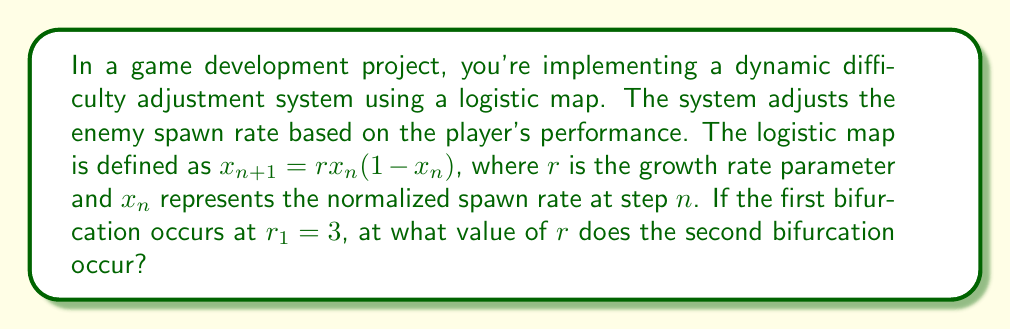Can you answer this question? To solve this problem, we need to understand the behavior of the logistic map and its bifurcations:

1. The logistic map is given by the equation $x_{n+1} = rx_n(1-x_n)$, where $r$ is the growth rate parameter.

2. As $r$ increases, the behavior of the system changes:
   - For $0 < r < 1$, the system converges to 0.
   - For $1 < r < 3$, the system converges to a single non-zero fixed point.
   - At $r = 3$, the first bifurcation occurs, and the system oscillates between two values.

3. The second bifurcation occurs when the system transitions from a 2-cycle to a 4-cycle.

4. The relationship between successive bifurcation points follows the Feigenbaum constant $\delta \approx 4.669201...$.

5. Let $r_1 = 3$ be the first bifurcation point and $r_2$ be the second bifurcation point.

6. The Feigenbaum constant relates these points as follows:
   $$\delta \approx \frac{r_3 - r_2}{r_2 - r_1}$$

7. We can approximate $r_2$ using:
   $$r_2 \approx r_1 + \frac{r_3 - r_2}{\delta}$$

8. The exact value of $r_2$ is known to be approximately 3.449490...

9. In game development, this value represents the point where the enemy spawn rate begins to exhibit more complex behavior, potentially making the game more challenging and unpredictable for the player.
Answer: $r_2 \approx 3.449490$ 